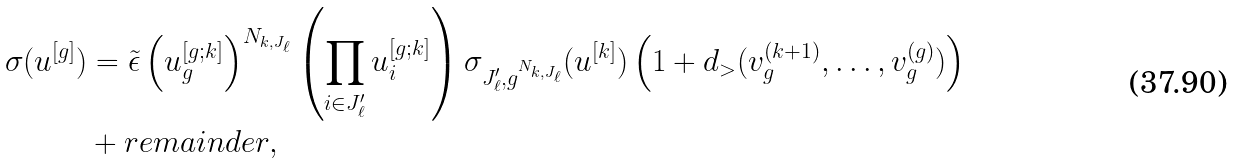Convert formula to latex. <formula><loc_0><loc_0><loc_500><loc_500>\sigma ( u ^ { [ g ] } ) & = \tilde { \epsilon } \left ( u _ { g } ^ { [ g ; k ] } \right ) ^ { N _ { k , J _ { \ell } } } \left ( \prod _ { i \in J _ { \ell } ^ { \prime } } u _ { i } ^ { [ g ; k ] } \right ) \sigma _ { J _ { \ell } ^ { \prime } , g ^ { N _ { k , J _ { \ell } } } } ( u ^ { [ k ] } ) \left ( 1 + d _ { > } ( v ^ { ( k + 1 ) } _ { g } , \dots , v ^ { ( g ) } _ { g } ) \right ) \\ & + r e m a i n d e r ,</formula> 